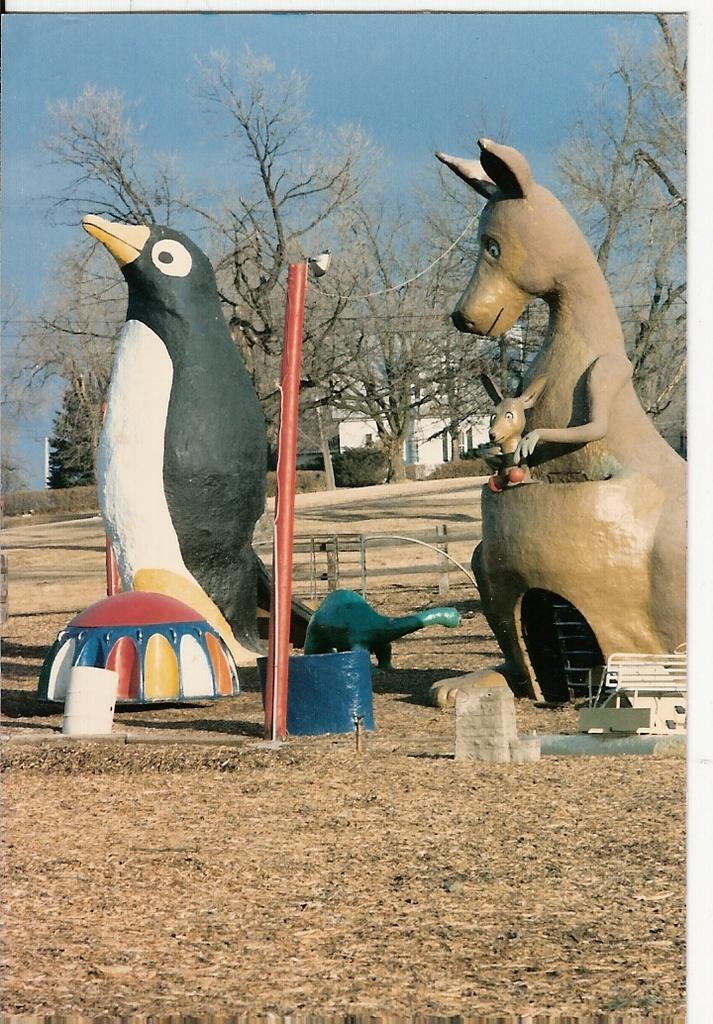In one or two sentences, can you explain what this image depicts? In this image, we can see few decorative items, pole, bench, wooden fencing. Background we can see house, trees, plants and sky. 